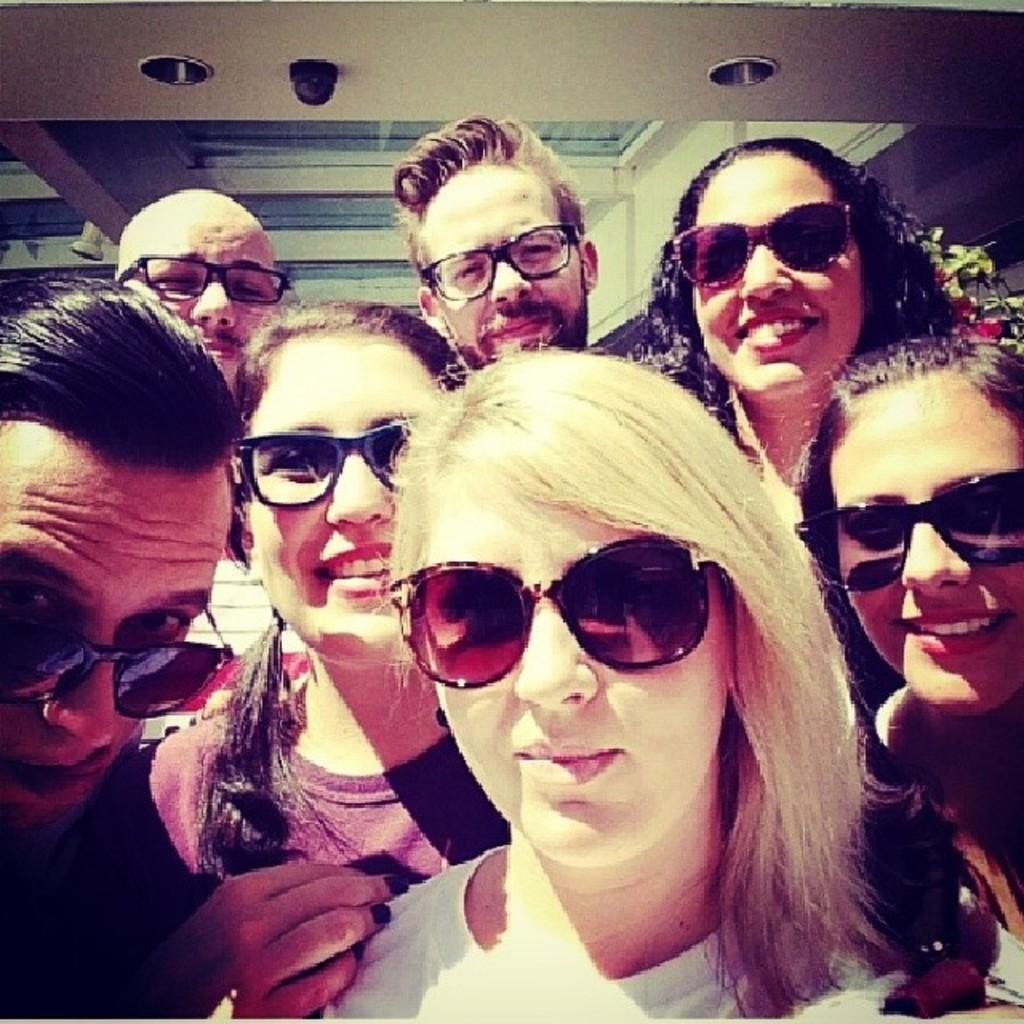What is the main subject in the foreground of the picture? There is a group of people in the foreground of the picture. What can be seen at the top of the image? There is a ceiling visible at the top of the image. What is located in the background of the image? There is a building in the background of the image. What type of vegetation is on the right side of the image? There is a plant on the right side of the image. What type of fork is being used to test the theory in the image? There is no fork or theory present in the image; it features a group of people, a ceiling, a building in the background, and a plant on the right side. 